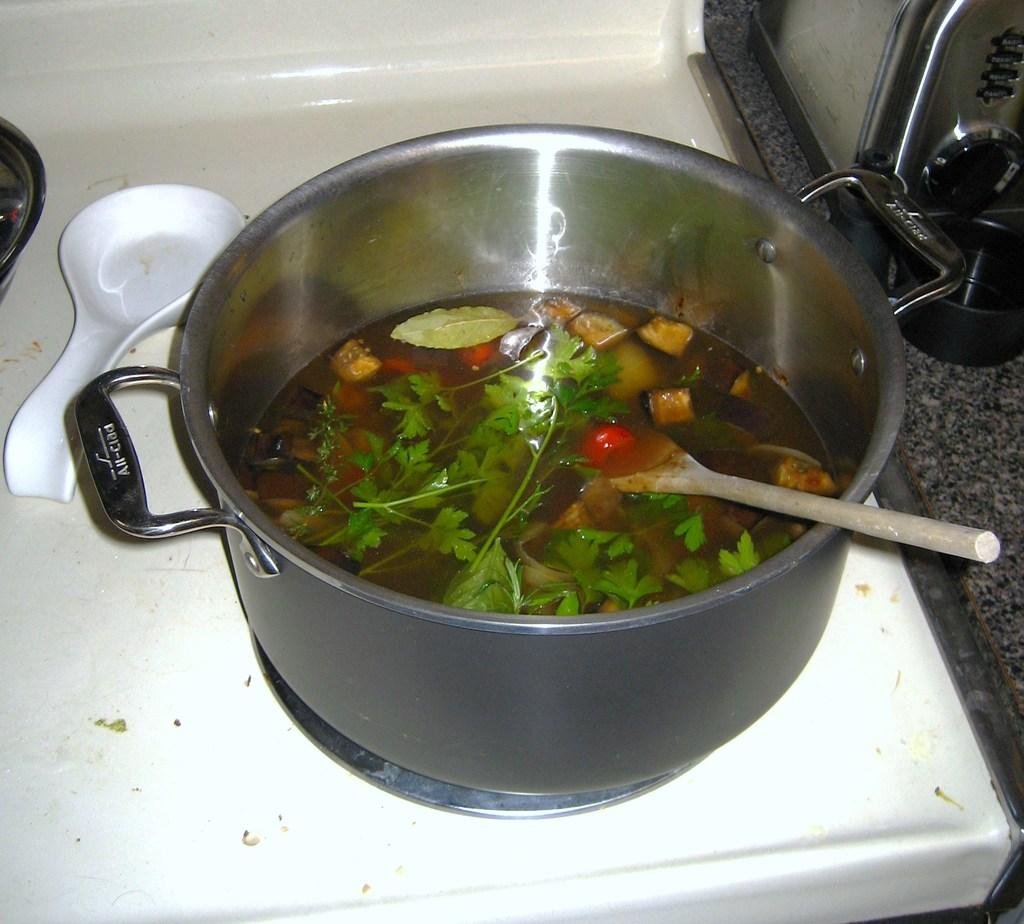What is in the bowl that is visible in the image? There is a bowl with soup in the image. What utensil is used for eating the soup? There is a spoon in the bowl. What can be seen in the background of the image? There is a stove in the background of the image. Is there another spoon visible in the image? Yes, there is a spoon on the stove in the background. What type of shock can be seen affecting the soup in the image? There is no shock visible in the image; it is a bowl of soup with a spoon in it. 